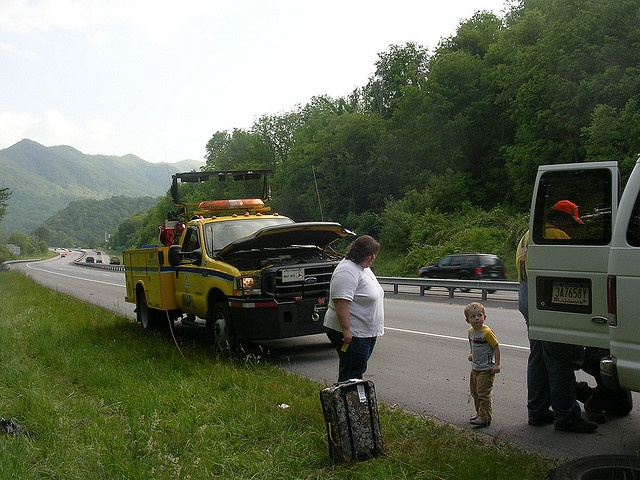Describe the objects in this image and their specific colors. I can see truck in white, black, darkgreen, gray, and maroon tones, car in white, black, gray, and darkgreen tones, truck in white, black, gray, and darkgreen tones, people in white, black, gray, olive, and maroon tones, and people in white, black, darkgray, gray, and lightgray tones in this image. 